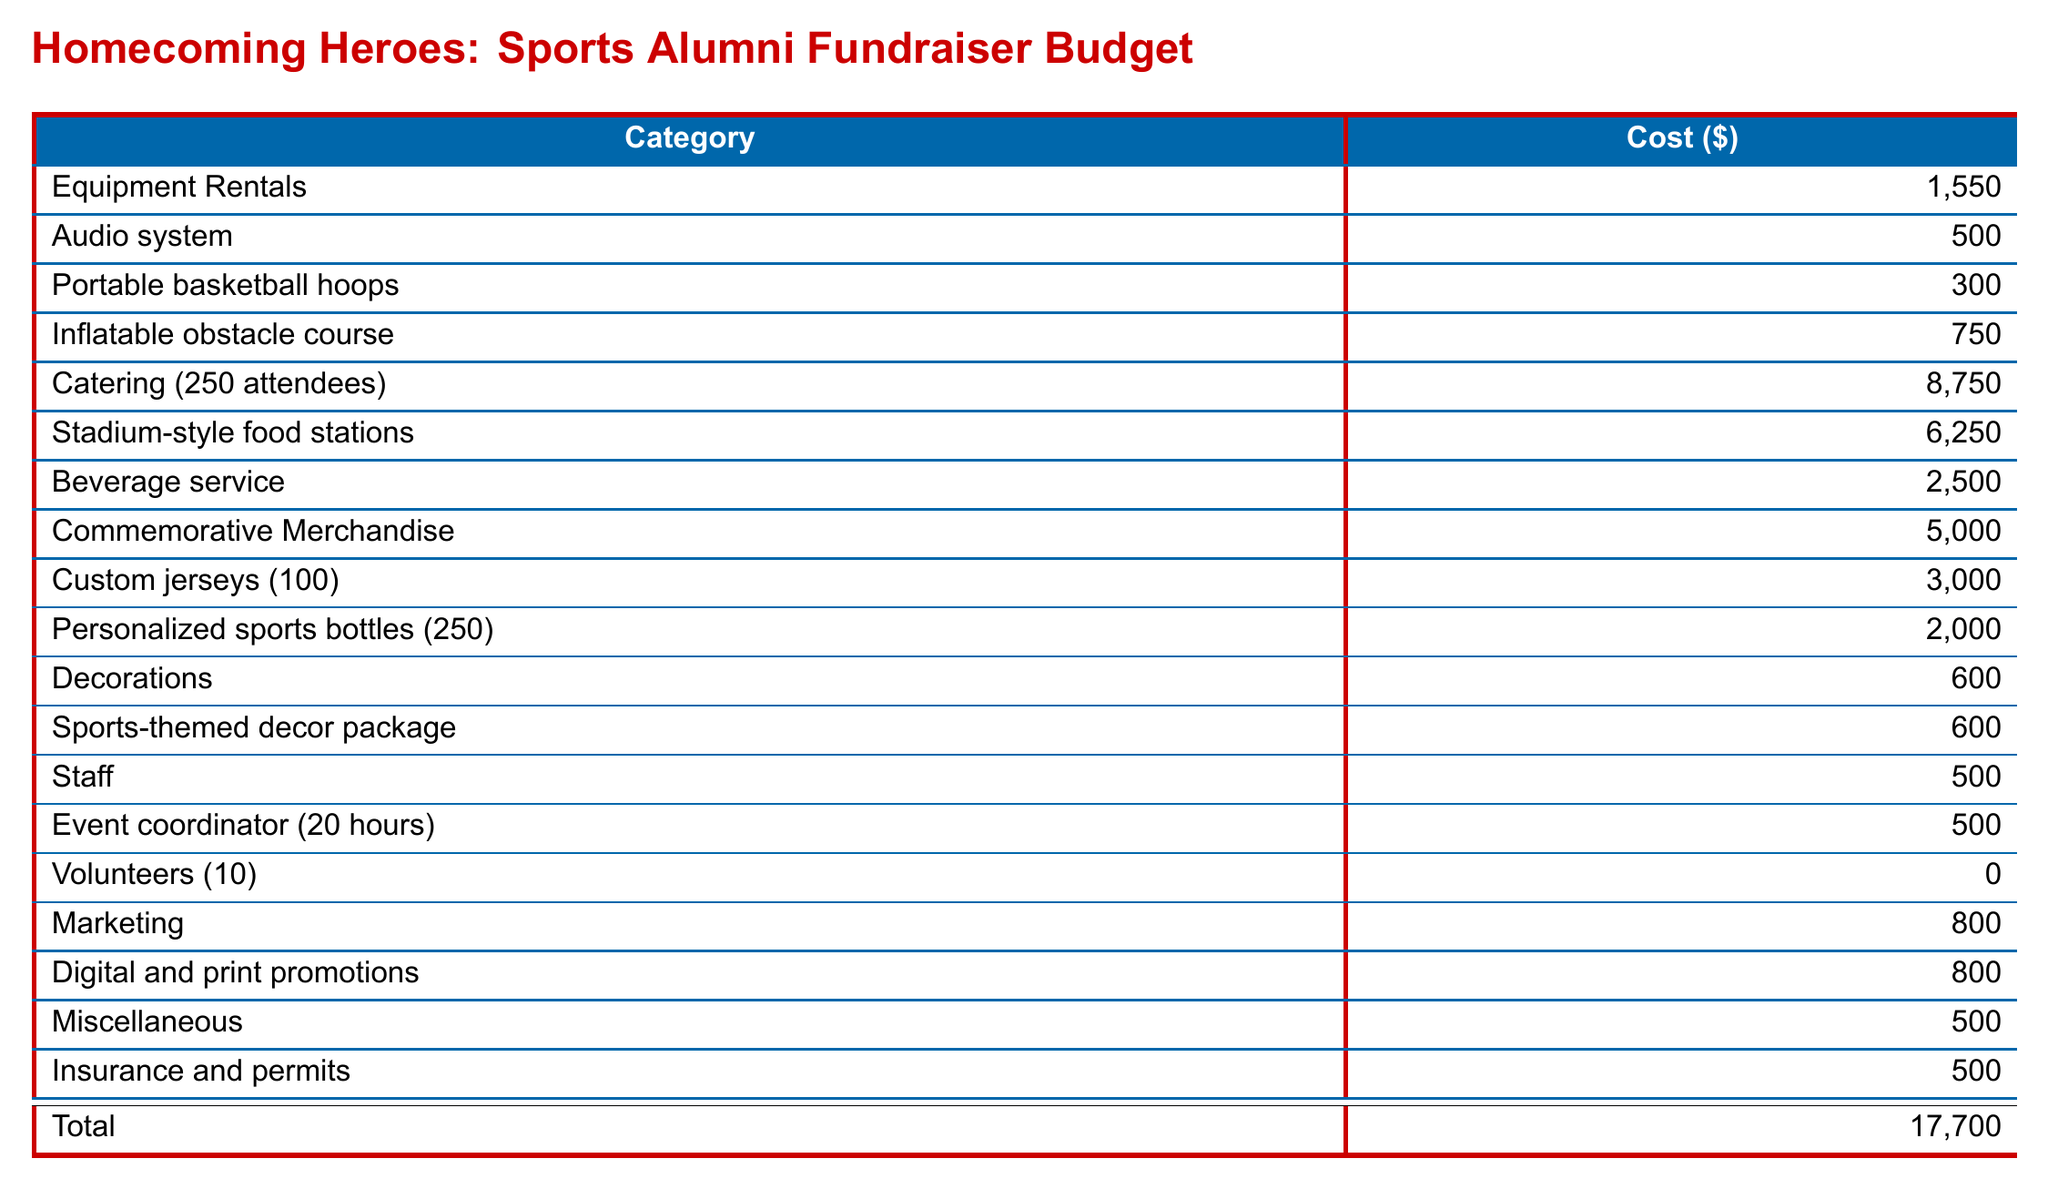what is the total cost of the fundraiser? The total cost is listed at the bottom of the budget, which sums all expenses, indicating a total of $17,700.
Answer: $17,700 how many attendees are expected at the event? The expected attendance is explicitly stated in the event details section of the document, which mentions 250 attendees.
Answer: 250 what is the cost for catering? The catering cost for 250 attendees is specified in the budget under Catering, amounting to $8,750.
Answer: $8,750 how many portable basketball hoops are included in the equipment rentals? The document specifies that the cost of portable basketball hoops in the equipment rentals category is $300, indicating their inclusion, but doesn't provide a quantity.
Answer: 1 what is the cost of the custom jerseys? The budget lists the cost of custom jerseys for 100 units as $3,000 under the Commemorative Merchandise section.
Answer: $3,000 what is the date of the event? The date of the event is mentioned in the Event Details section, clearly listed as October 15, 2023.
Answer: October 15, 2023 what is the cost for the audio system rental? The budget specifies the audio system rental cost as $500 in the Equipment Rentals category.
Answer: $500 how much funding could be saved with additional sponsorships? The document notes that additional sponsorships may reduce overall costs, implying potential savings but does not specify an amount.
Answer: unspecified how many volunteers are expected for the event? The budget indicates that there will be 10 volunteers assisting at the event, contributing to reducing staffing expenses.
Answer: 10 